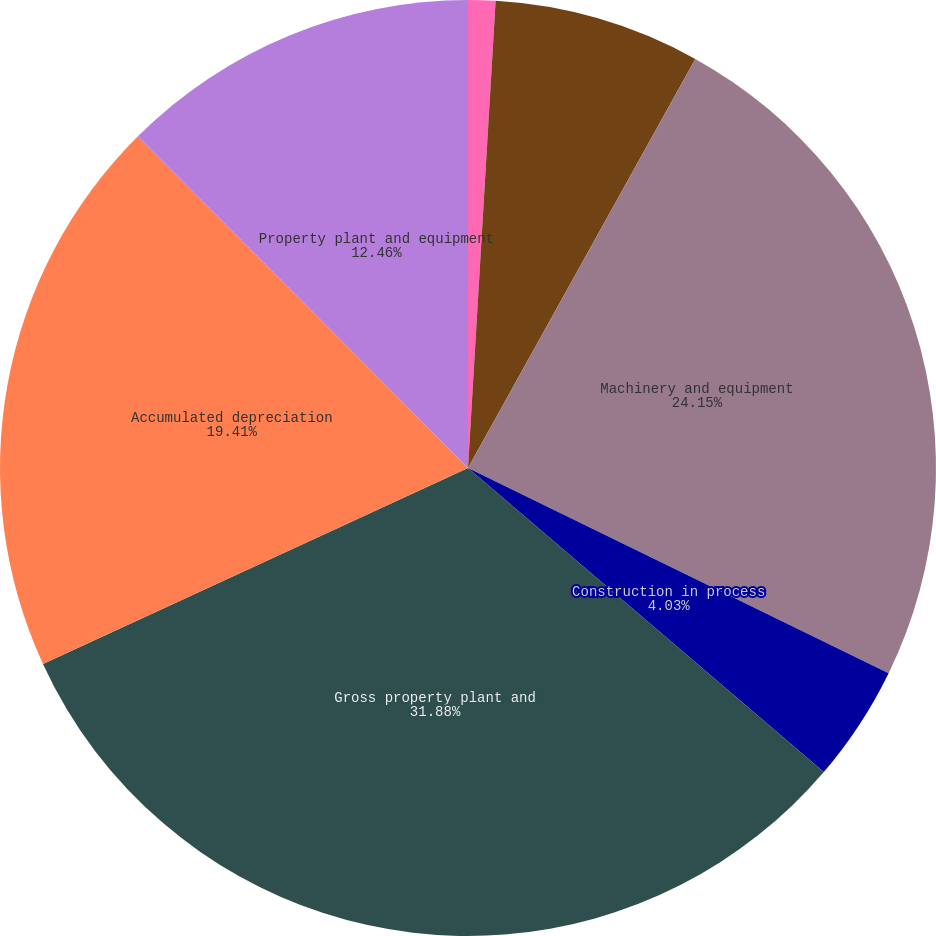Convert chart. <chart><loc_0><loc_0><loc_500><loc_500><pie_chart><fcel>Land and improvements<fcel>Buildings and leasehold<fcel>Machinery and equipment<fcel>Construction in process<fcel>Gross property plant and<fcel>Accumulated depreciation<fcel>Property plant and equipment<nl><fcel>0.94%<fcel>7.13%<fcel>24.15%<fcel>4.03%<fcel>31.87%<fcel>19.41%<fcel>12.46%<nl></chart> 